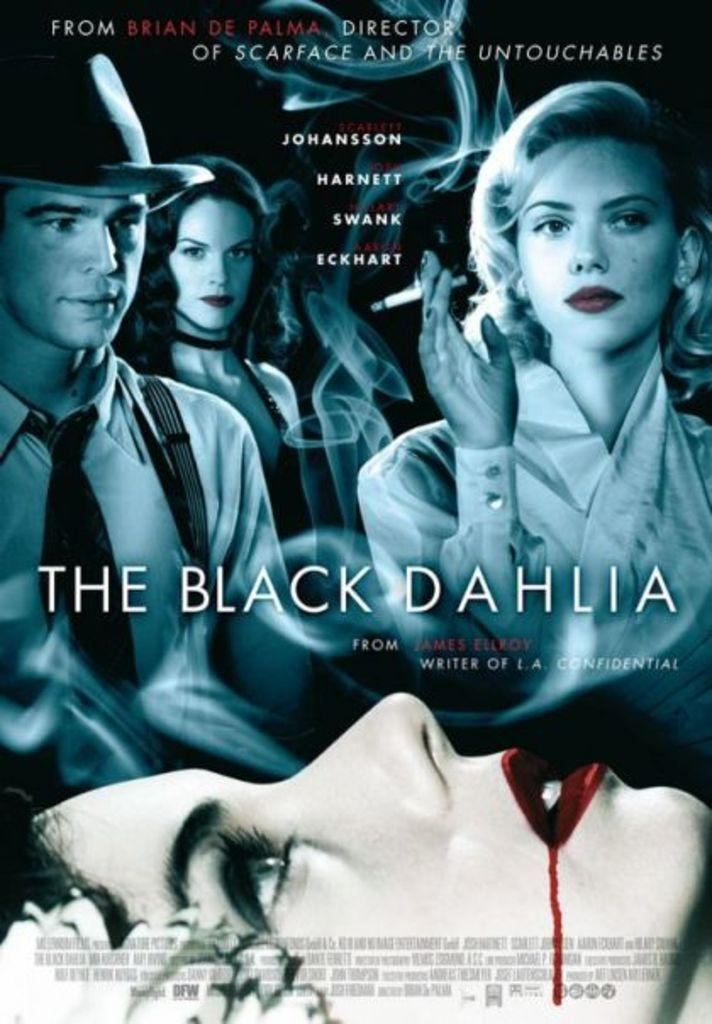Provide a one-sentence caption for the provided image. Poster of themovie The Black Dahlia, picturing Scarlet Johanson. 